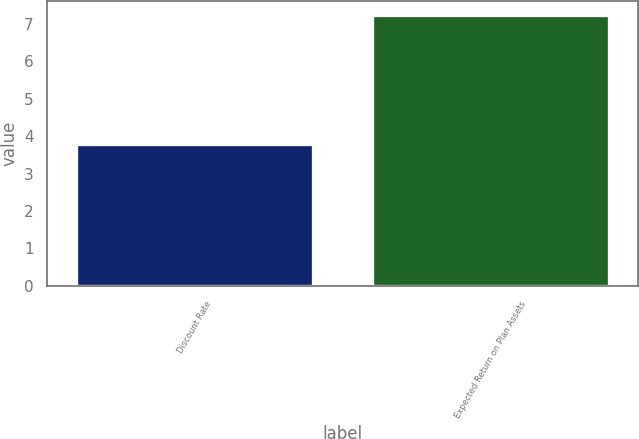<chart> <loc_0><loc_0><loc_500><loc_500><bar_chart><fcel>Discount Rate<fcel>Expected Return on Plan Assets<nl><fcel>3.8<fcel>7.25<nl></chart> 